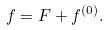Convert formula to latex. <formula><loc_0><loc_0><loc_500><loc_500>f = F + f ^ { ( 0 ) } .</formula> 